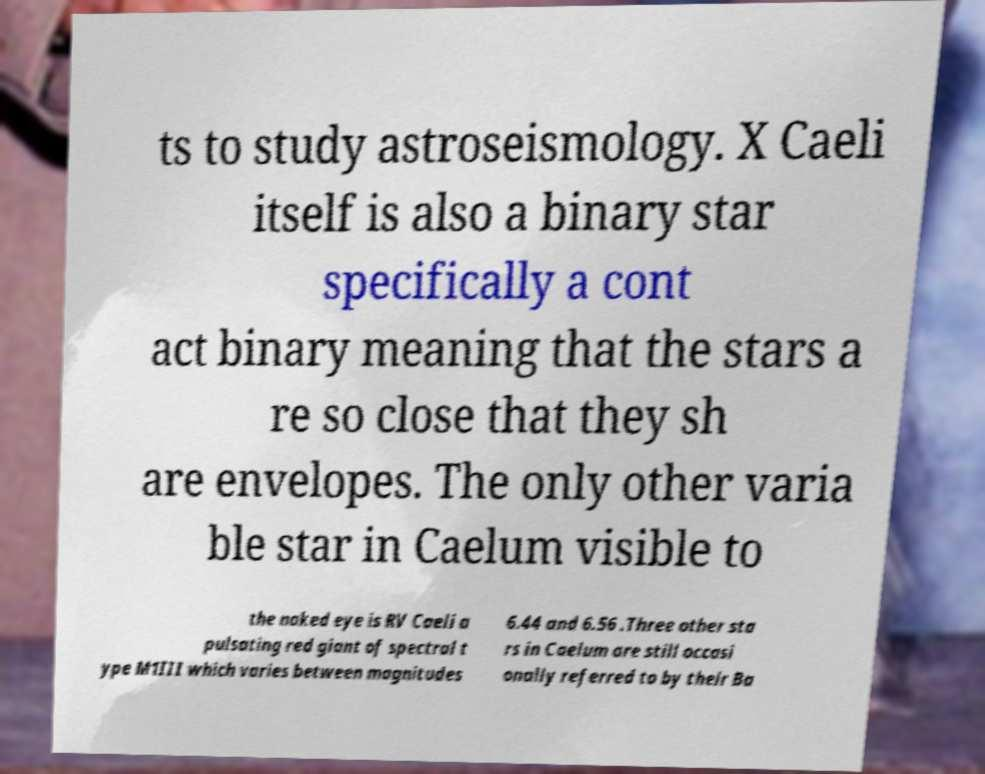Please read and relay the text visible in this image. What does it say? ts to study astroseismology. X Caeli itself is also a binary star specifically a cont act binary meaning that the stars a re so close that they sh are envelopes. The only other varia ble star in Caelum visible to the naked eye is RV Caeli a pulsating red giant of spectral t ype M1III which varies between magnitudes 6.44 and 6.56 .Three other sta rs in Caelum are still occasi onally referred to by their Ba 